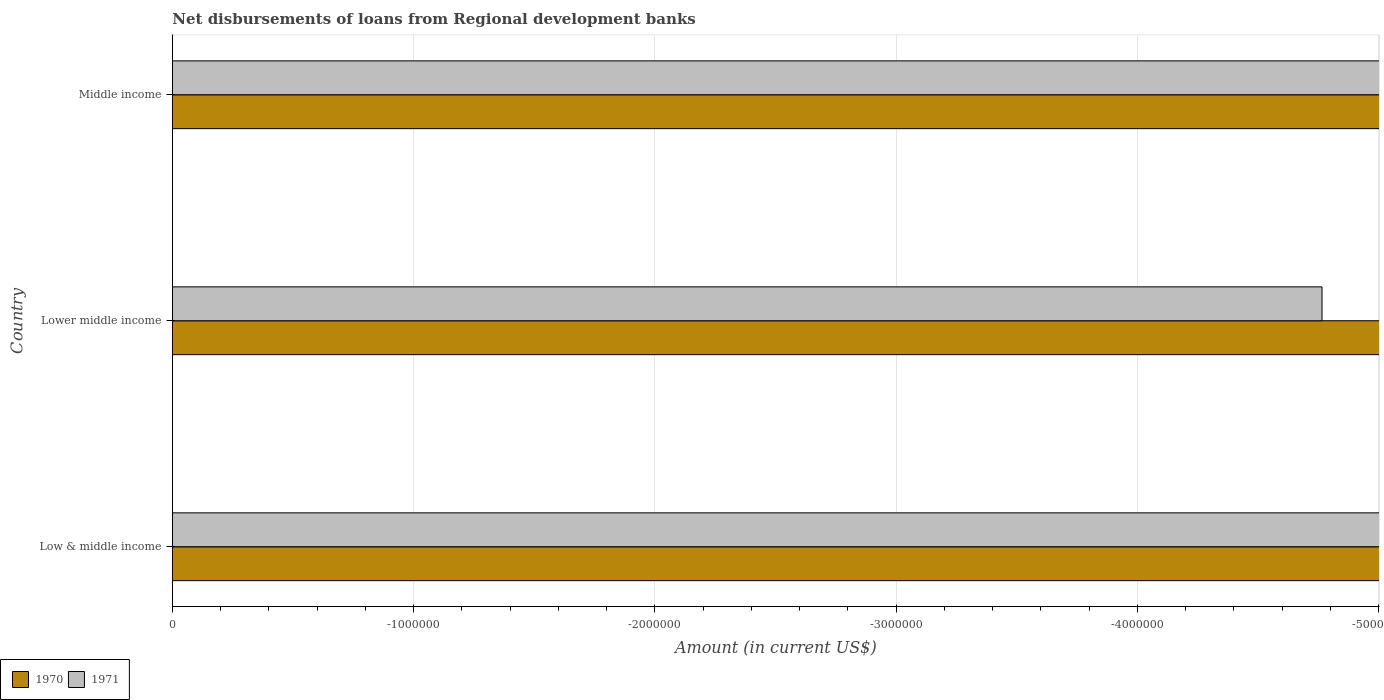How many different coloured bars are there?
Give a very brief answer. 0. Are the number of bars on each tick of the Y-axis equal?
Provide a short and direct response. Yes. How many bars are there on the 2nd tick from the top?
Ensure brevity in your answer.  0. What is the label of the 1st group of bars from the top?
Provide a succinct answer. Middle income. What is the amount of disbursements of loans from regional development banks in 1970 in Middle income?
Give a very brief answer. 0. What is the average amount of disbursements of loans from regional development banks in 1971 per country?
Provide a succinct answer. 0. In how many countries, is the amount of disbursements of loans from regional development banks in 1971 greater than -4200000 US$?
Provide a short and direct response. 0. How many bars are there?
Make the answer very short. 0. How many countries are there in the graph?
Ensure brevity in your answer.  3. What is the difference between two consecutive major ticks on the X-axis?
Your answer should be very brief. 1.00e+06. Are the values on the major ticks of X-axis written in scientific E-notation?
Offer a terse response. No. Does the graph contain any zero values?
Your answer should be compact. Yes. Does the graph contain grids?
Provide a short and direct response. Yes. What is the title of the graph?
Give a very brief answer. Net disbursements of loans from Regional development banks. What is the label or title of the X-axis?
Provide a succinct answer. Amount (in current US$). What is the label or title of the Y-axis?
Your answer should be compact. Country. What is the Amount (in current US$) of 1970 in Lower middle income?
Keep it short and to the point. 0. What is the Amount (in current US$) in 1971 in Lower middle income?
Keep it short and to the point. 0. What is the Amount (in current US$) in 1970 in Middle income?
Your answer should be compact. 0. What is the Amount (in current US$) in 1971 in Middle income?
Keep it short and to the point. 0. What is the average Amount (in current US$) in 1971 per country?
Offer a terse response. 0. 